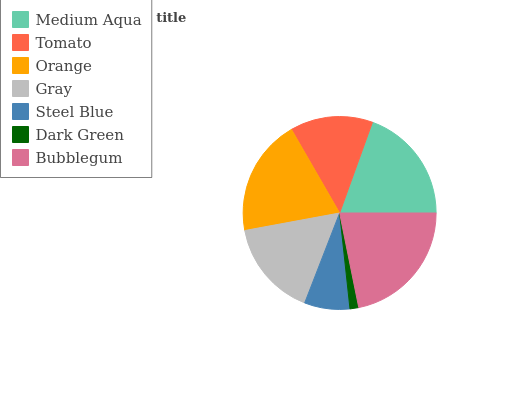Is Dark Green the minimum?
Answer yes or no. Yes. Is Bubblegum the maximum?
Answer yes or no. Yes. Is Tomato the minimum?
Answer yes or no. No. Is Tomato the maximum?
Answer yes or no. No. Is Medium Aqua greater than Tomato?
Answer yes or no. Yes. Is Tomato less than Medium Aqua?
Answer yes or no. Yes. Is Tomato greater than Medium Aqua?
Answer yes or no. No. Is Medium Aqua less than Tomato?
Answer yes or no. No. Is Gray the high median?
Answer yes or no. Yes. Is Gray the low median?
Answer yes or no. Yes. Is Orange the high median?
Answer yes or no. No. Is Dark Green the low median?
Answer yes or no. No. 